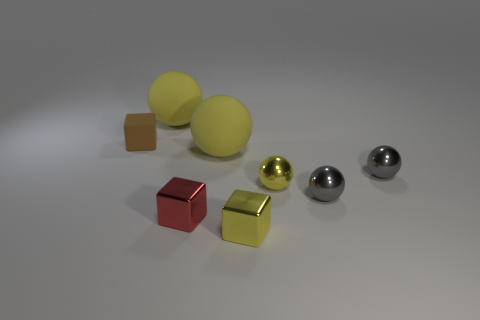How many yellow spheres must be subtracted to get 1 yellow spheres? 2 Subtract all brown cylinders. How many yellow spheres are left? 3 Subtract all small yellow spheres. How many spheres are left? 4 Subtract all purple spheres. Subtract all red cylinders. How many spheres are left? 5 Add 1 cyan shiny things. How many objects exist? 9 Subtract all blocks. How many objects are left? 5 Subtract 0 green balls. How many objects are left? 8 Subtract all yellow metal blocks. Subtract all gray metallic spheres. How many objects are left? 5 Add 3 tiny yellow balls. How many tiny yellow balls are left? 4 Add 5 big purple metallic spheres. How many big purple metallic spheres exist? 5 